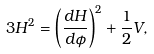Convert formula to latex. <formula><loc_0><loc_0><loc_500><loc_500>3 H ^ { 2 } = \left ( \frac { d H } { d \phi } \right ) ^ { 2 } + \frac { 1 } { 2 } V ,</formula> 